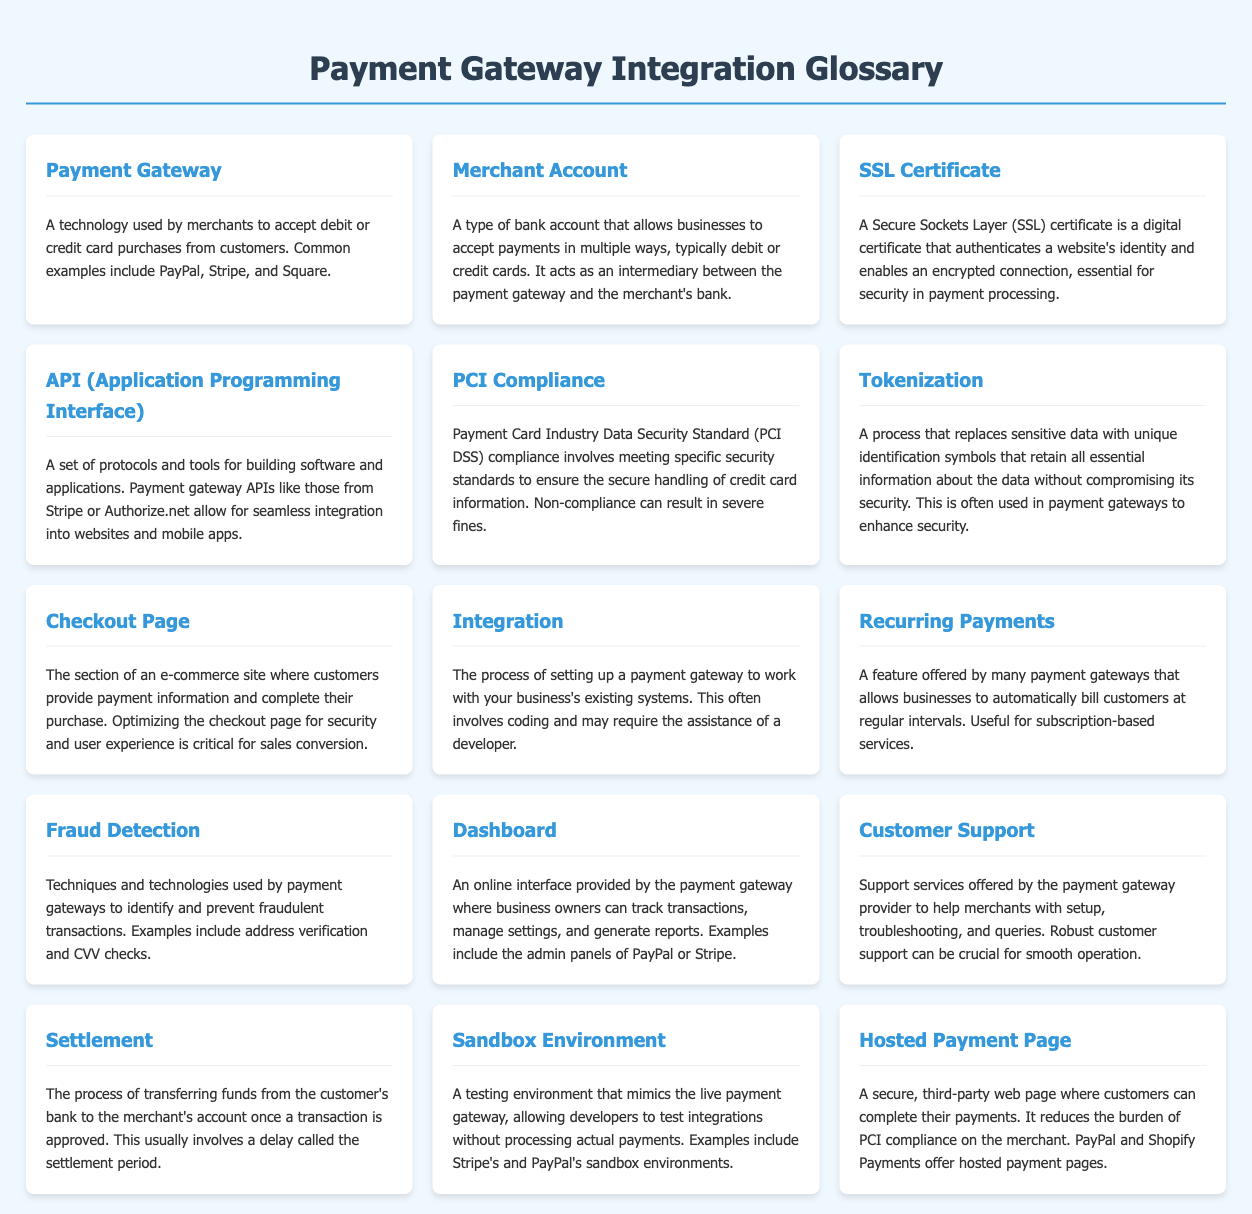What is a payment gateway? A payment gateway is defined as a technology used by merchants to accept debit or credit card purchases from customers.
Answer: A technology used by merchants to accept debit or credit card purchases from customers What does PCI compliance stand for? PCI compliance stands for Payment Card Industry Data Security Standard compliance, which involves meeting specific security standards.
Answer: Payment Card Industry Data Security Standard What is tokenization? Tokenization is explained as a process that replaces sensitive data with unique identification symbols for security.
Answer: A process that replaces sensitive data with unique identification symbols What feature allows businesses to automatically bill customers? The feature that allows businesses to automatically bill customers is referred to as recurring payments.
Answer: Recurring payments What is the purpose of a sandbox environment? The purpose of a sandbox environment is to provide a testing environment for developers to test integrations without processing actual payments.
Answer: A testing environment mimicking the live payment gateway What provides merchants an online interface to track transactions? The dashboard provides business owners with an online interface to track transactions, manage settings, and generate reports.
Answer: Dashboard How does tokenization enhance security? Tokenization enhances security by replacing sensitive data with unique identification symbols that retain essential information without compromising security.
Answer: Enhances security What do hosted payment pages reduce for merchants? Hosted payment pages reduce the burden of PCI compliance on the merchant.
Answer: The burden of PCI compliance How many terms are included in the glossary? The glossary includes a total of 16 terms related to payment gateway integration.
Answer: 16 terms 